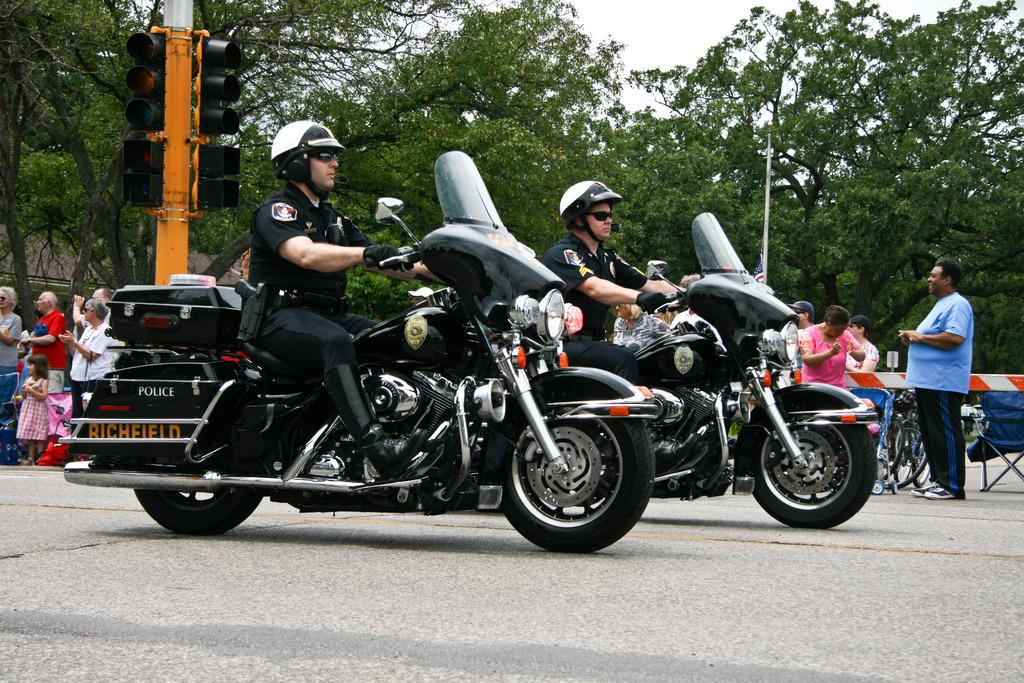How many persons are in the image? There are two persons in the image. What protective gear are the persons wearing? Both persons are wearing helmets, goggles, and gloves. What activity are the persons engaged in? The persons are riding bikes. What can be seen in the background of the image? There is a traffic light, a tree, sky, a pole, a flag, and some people standing in the background of the image. What type of breakfast is being prepared by the persons in the image? There is no indication in the image that the persons are preparing or eating breakfast. In which direction are the persons riding their bikes? The direction in which the persons are riding their bikes cannot be determined from the image alone. 